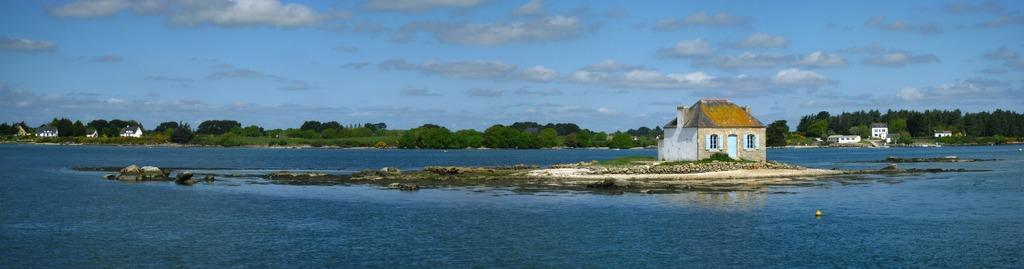What is the primary element visible in the image? There is water in the image. What other natural elements can be seen in the image? There are trees in the image. Are there any man-made structures visible? Yes, there are buildings in the image. What is the yellow object in the water? There is a yellow object in the water, but its nature or purpose cannot be determined from the image. What can be seen in the background of the image? There are clouds and the sky visible in the background of the image. What type of trousers are the clouds wearing in the image? The clouds are not wearing trousers, as they are a natural atmospheric phenomenon and not human-like entities. 